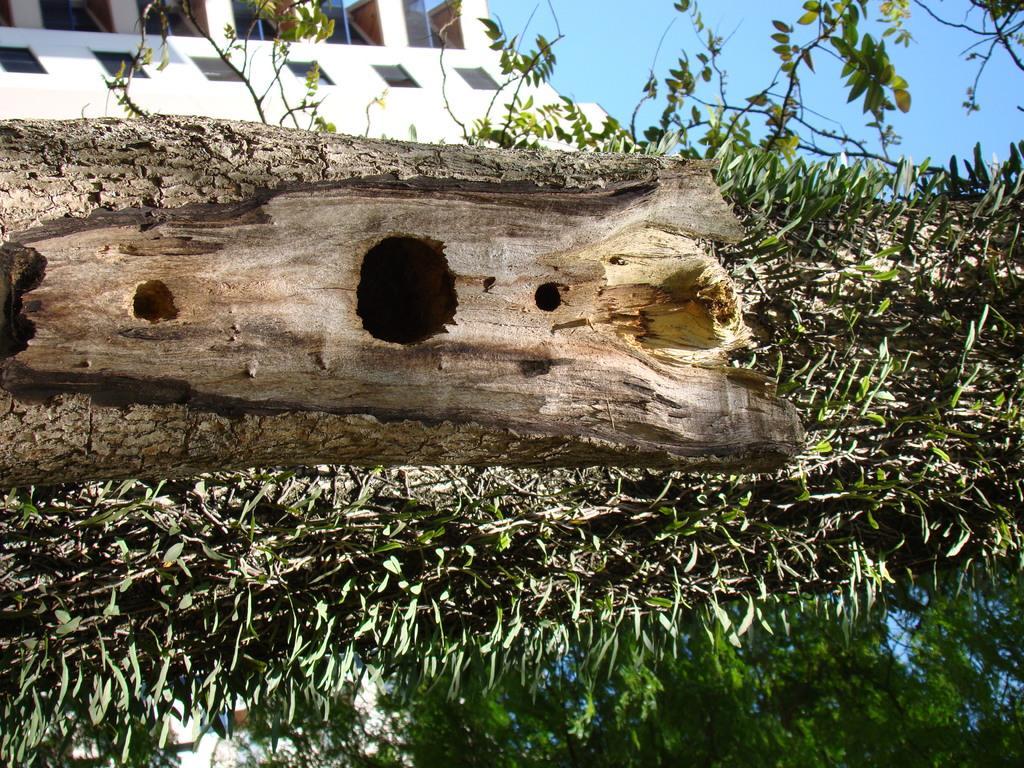Please provide a concise description of this image. In the image there is a wooden log and around that wooden log there are some plants and in the background there is a building. 